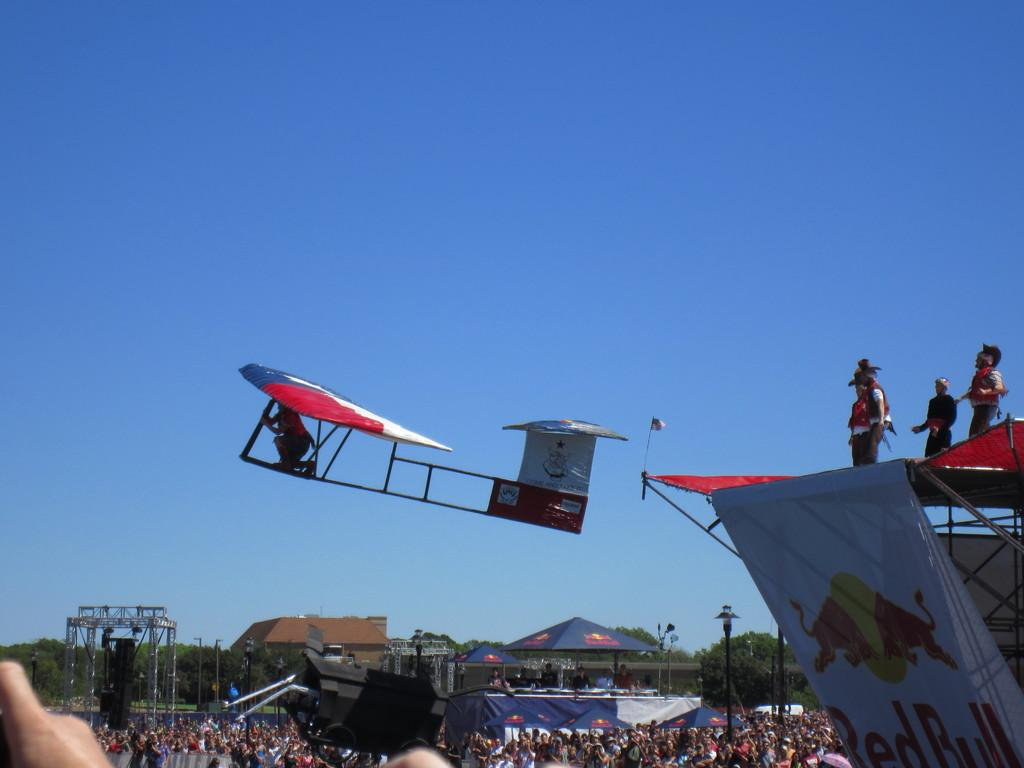<image>
Share a concise interpretation of the image provided. A Red Bull ad is on the side of a big plane 